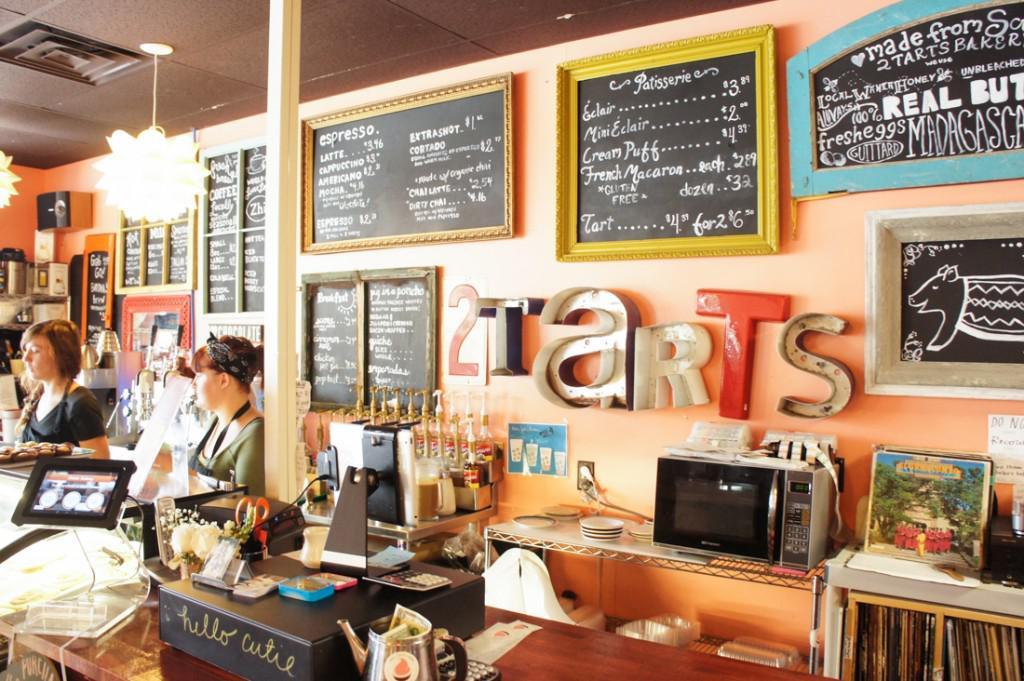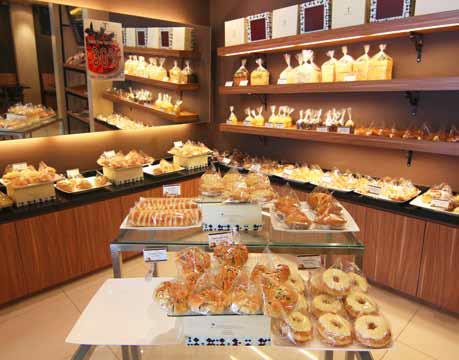The first image is the image on the left, the second image is the image on the right. For the images shown, is this caption "There is a rounded display case." true? Answer yes or no. No. 